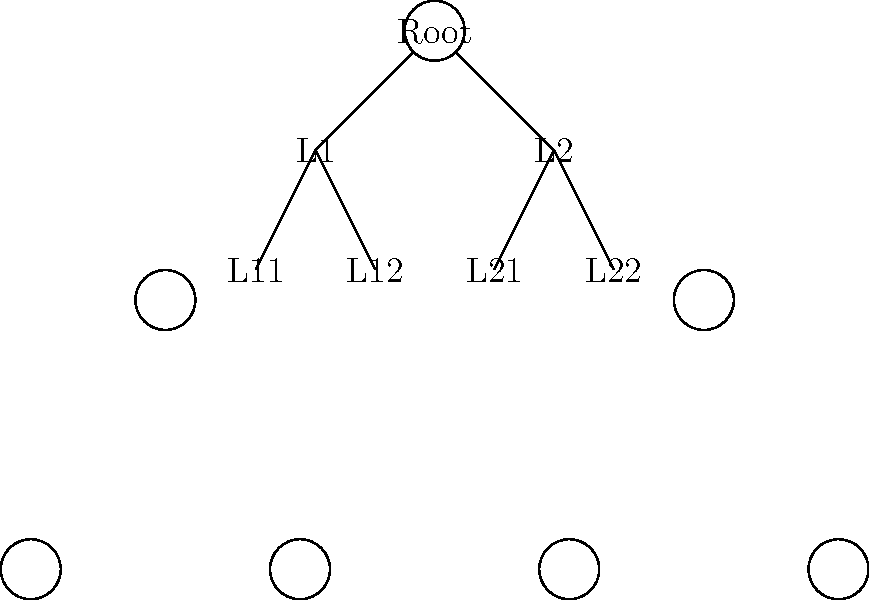Consider the B-tree structure shown above for database indexing. If we want to minimize the number of disk I/O operations when searching for a specific key, what is the optimal maximum number of child nodes for each internal node in this B-tree, assuming each node fits exactly on one disk block? To determine the optimal maximum number of child nodes for each internal node in a B-tree, we need to consider the trade-off between the tree's height and the number of comparisons required at each node. Here's a step-by-step explanation:

1. In a B-tree, each internal node contains keys and pointers to child nodes. The number of keys is always one less than the number of pointers to child nodes.

2. Let's denote the maximum number of child nodes as $n$. This means each internal node can have up to $n-1$ keys.

3. The goal is to minimize disk I/O operations, which primarily occur when accessing a new node (i.e., a new disk block).

4. To minimize the number of disk accesses, we want to maximize the branching factor (number of child nodes) while still fitting all the information in a single disk block.

5. The size of a disk block is typically 4KB or 8KB. Let's assume it's 4KB for this example.

6. Each key and pointer in the node requires some space. Let's assume:
   - Each key requires 8 bytes (e.g., for a long integer)
   - Each pointer requires 6 bytes (e.g., for a disk address)

7. The total space used by an internal node with $n$ child pointers and $n-1$ keys is:
   $$ 6n + 8(n-1) = 14n - 8 \text{ bytes} $$

8. To fit this in a 4KB (4096 bytes) block, we solve:
   $$ 14n - 8 \leq 4096 $$
   $$ 14n \leq 4104 $$
   $$ n \leq 293.14 $$

9. Since $n$ must be an integer, the maximum value it can take is 293.

10. Therefore, the optimal maximum number of child nodes for each internal node is 293, which allows for 292 keys per node.

This configuration maximizes the branching factor while ensuring each node fits in a single disk block, thus minimizing the number of disk I/O operations required for searches.
Answer: 293 